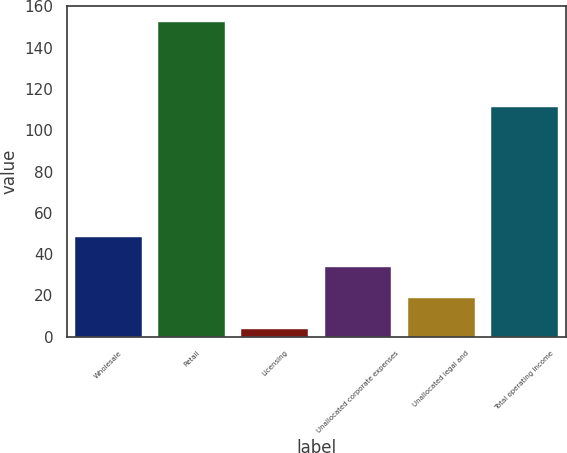<chart> <loc_0><loc_0><loc_500><loc_500><bar_chart><fcel>Wholesale<fcel>Retail<fcel>Licensing<fcel>Unallocated corporate expenses<fcel>Unallocated legal and<fcel>Total operating income<nl><fcel>48.41<fcel>152.5<fcel>3.8<fcel>33.54<fcel>18.67<fcel>111.4<nl></chart> 